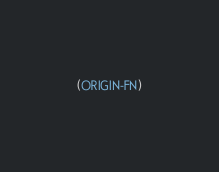Convert code to text. <code><loc_0><loc_0><loc_500><loc_500><_Lisp_>(ORIGIN-FN)
</code> 